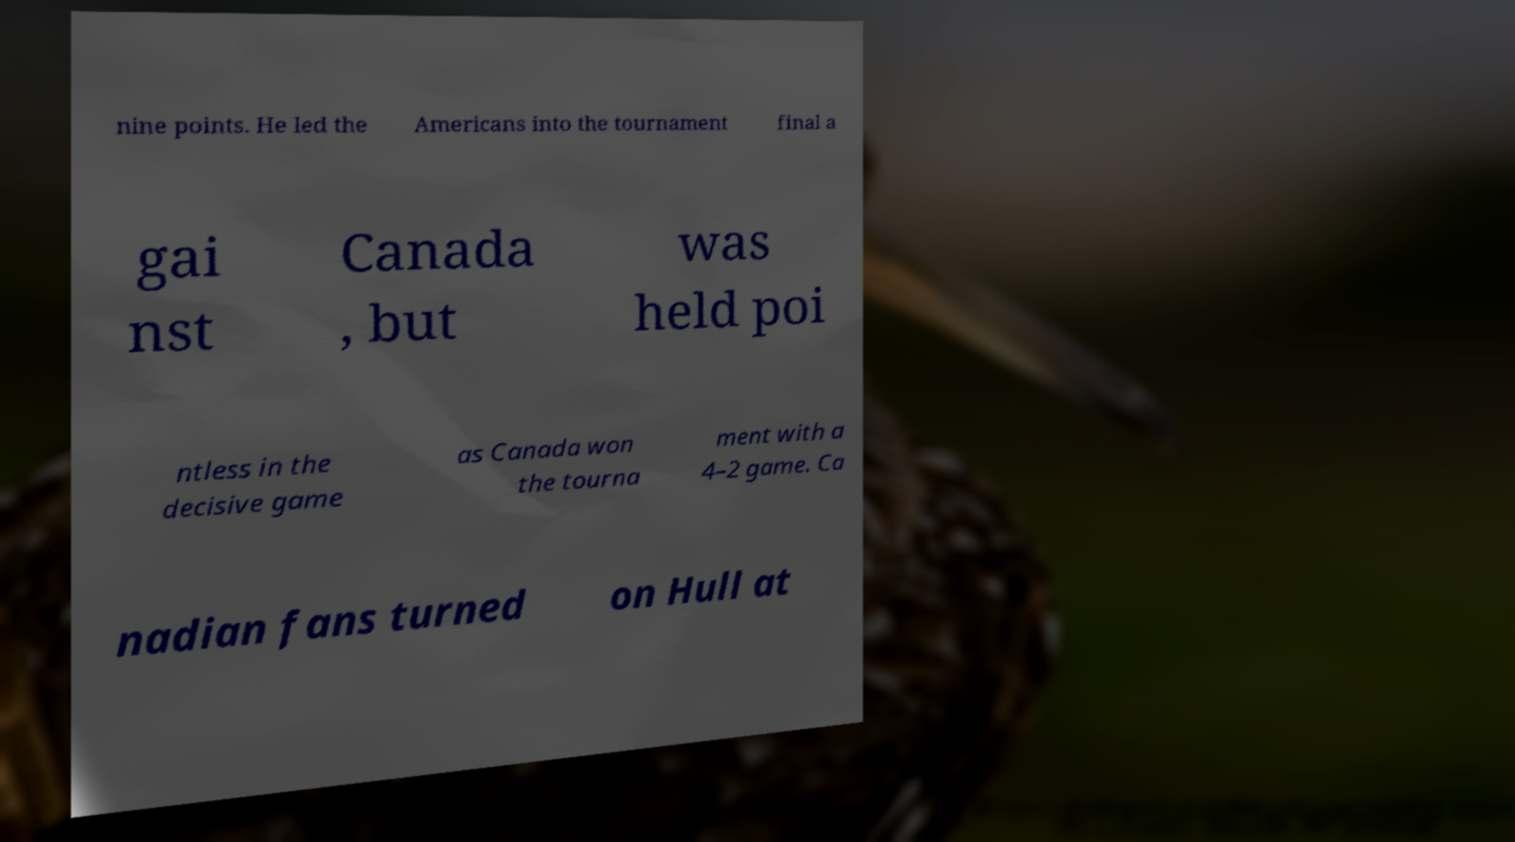Could you extract and type out the text from this image? nine points. He led the Americans into the tournament final a gai nst Canada , but was held poi ntless in the decisive game as Canada won the tourna ment with a 4–2 game. Ca nadian fans turned on Hull at 